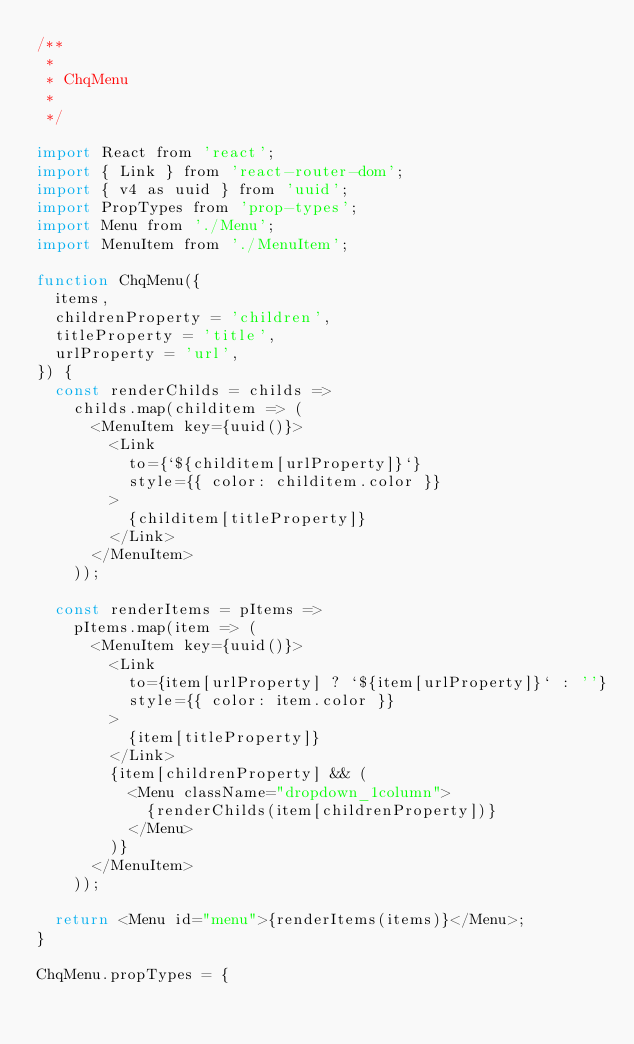Convert code to text. <code><loc_0><loc_0><loc_500><loc_500><_JavaScript_>/**
 *
 * ChqMenu
 *
 */

import React from 'react';
import { Link } from 'react-router-dom';
import { v4 as uuid } from 'uuid';
import PropTypes from 'prop-types';
import Menu from './Menu';
import MenuItem from './MenuItem';

function ChqMenu({
  items,
  childrenProperty = 'children',
  titleProperty = 'title',
  urlProperty = 'url',
}) {
  const renderChilds = childs =>
    childs.map(childitem => (
      <MenuItem key={uuid()}>
        <Link
          to={`${childitem[urlProperty]}`}
          style={{ color: childitem.color }}
        >
          {childitem[titleProperty]}
        </Link>
      </MenuItem>
    ));

  const renderItems = pItems =>
    pItems.map(item => (
      <MenuItem key={uuid()}>
        <Link
          to={item[urlProperty] ? `${item[urlProperty]}` : ''}
          style={{ color: item.color }}
        >
          {item[titleProperty]}
        </Link>
        {item[childrenProperty] && (
          <Menu className="dropdown_1column">
            {renderChilds(item[childrenProperty])}
          </Menu>
        )}
      </MenuItem>
    ));

  return <Menu id="menu">{renderItems(items)}</Menu>;
}

ChqMenu.propTypes = {</code> 